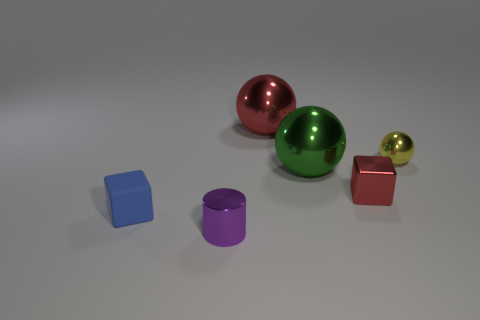Subtract all green metal balls. How many balls are left? 2 Subtract all cylinders. How many objects are left? 5 Add 3 tiny purple shiny blocks. How many objects exist? 9 Subtract all red cubes. How many cubes are left? 1 Subtract all cyan spheres. Subtract all gray blocks. How many spheres are left? 3 Subtract all cyan balls. How many yellow cylinders are left? 0 Subtract all large green metallic cylinders. Subtract all purple objects. How many objects are left? 5 Add 3 metal cylinders. How many metal cylinders are left? 4 Add 1 yellow metal balls. How many yellow metal balls exist? 2 Subtract 0 blue spheres. How many objects are left? 6 